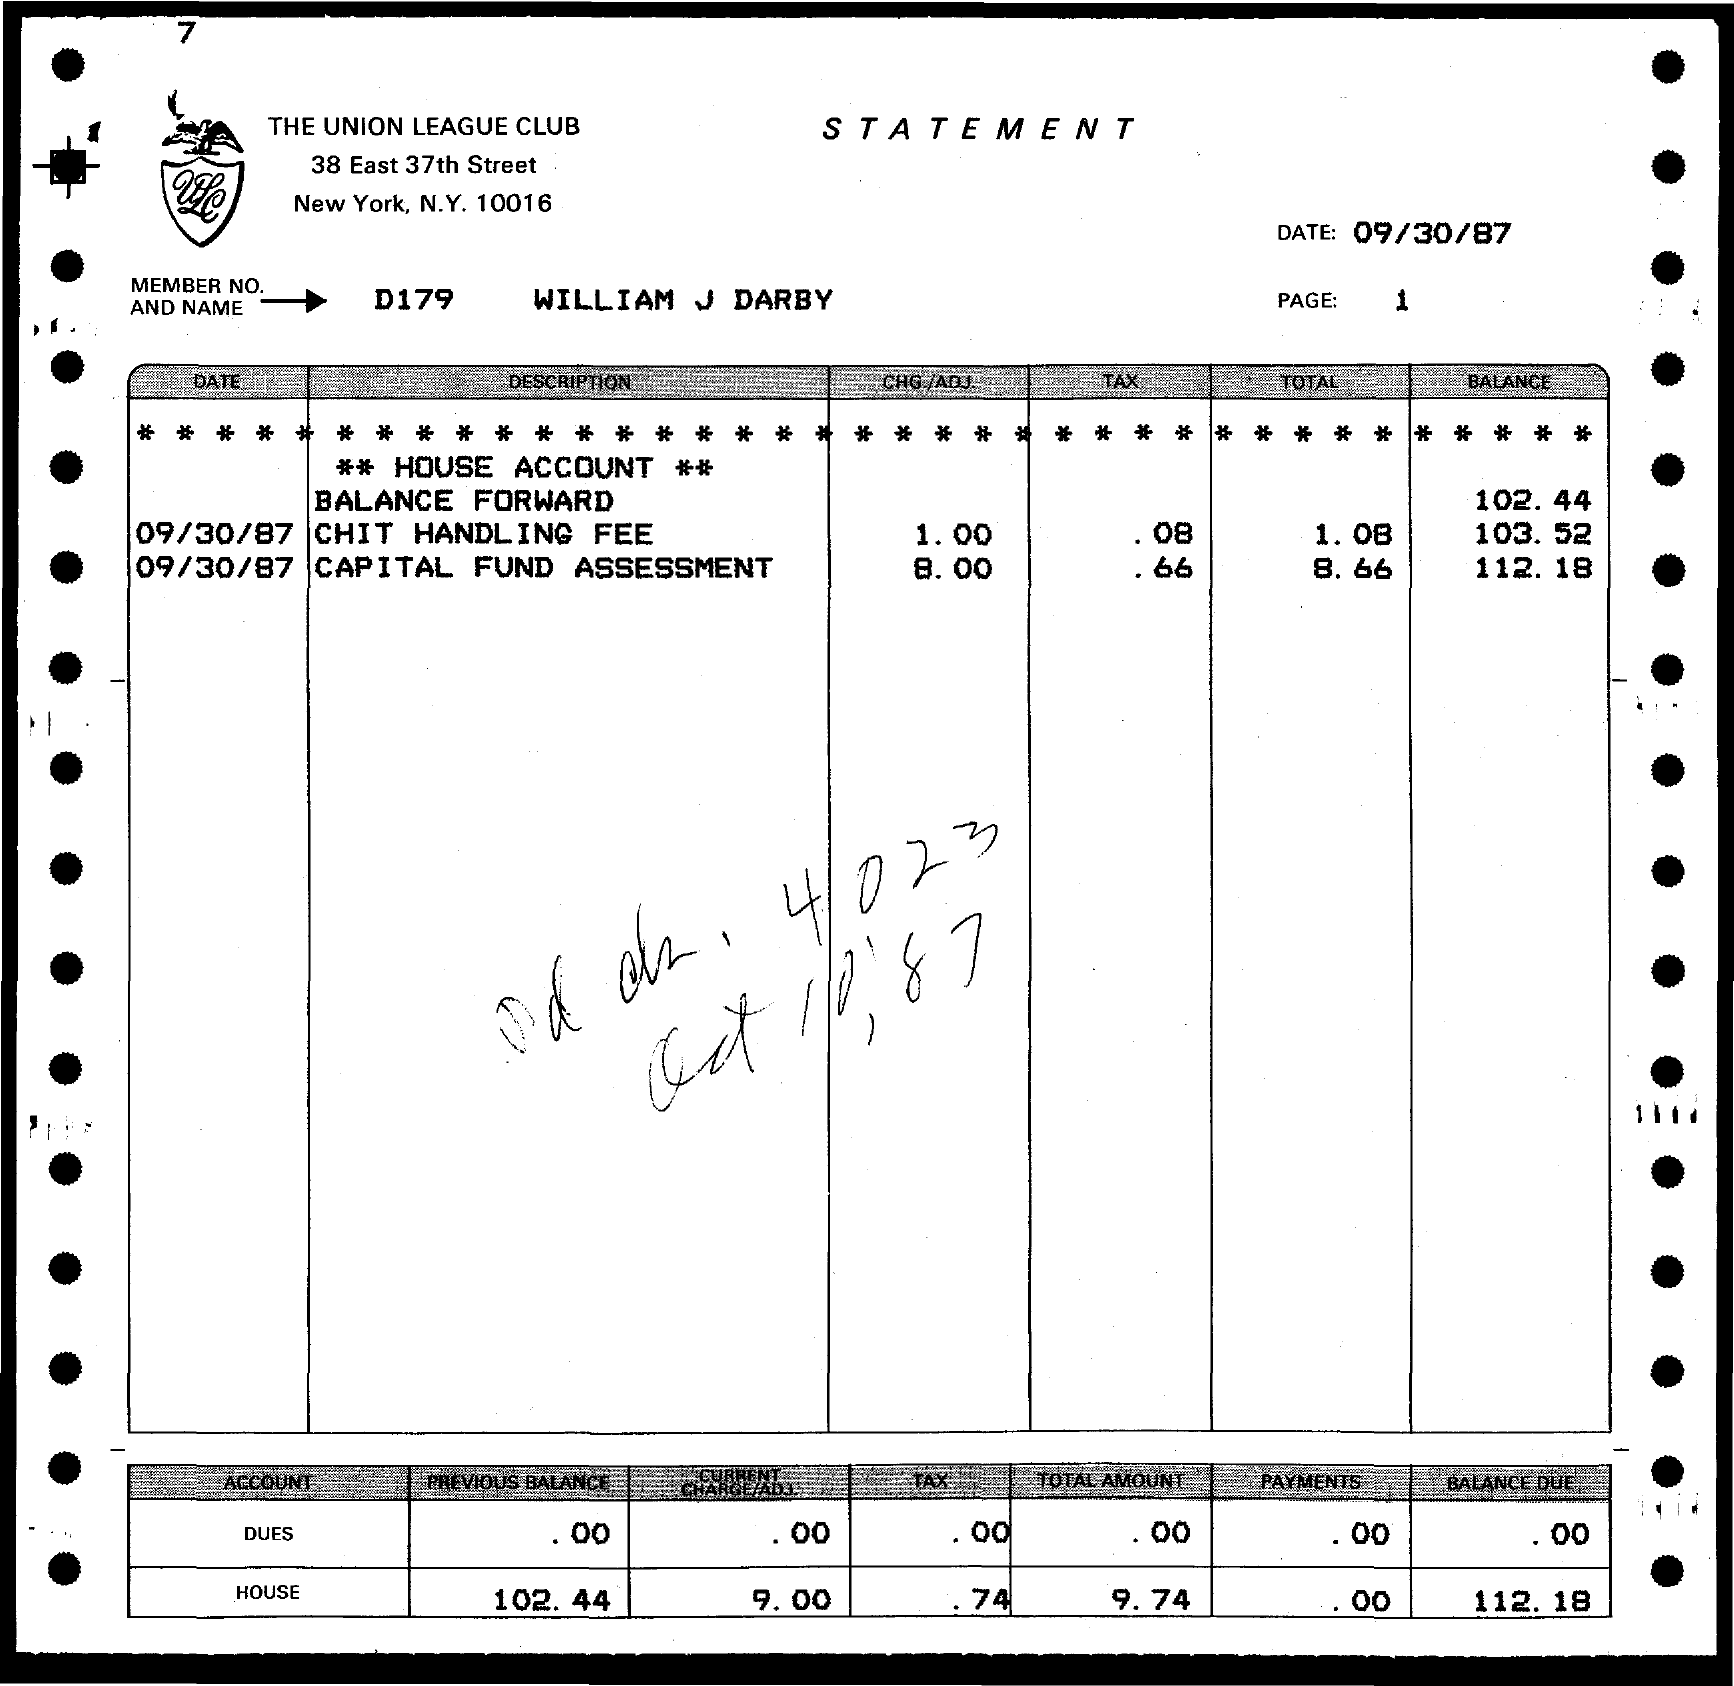Which club is mentioned in the letterhead?
Offer a very short reply. The Union League Club. Which date is mentioned in the statement?
Your response must be concise. 09/30/87. What is the MEMBER NO AND NAME?
Provide a succinct answer. D179 William J Darby. How much is the House Balance Due?
Ensure brevity in your answer.  112.18. 